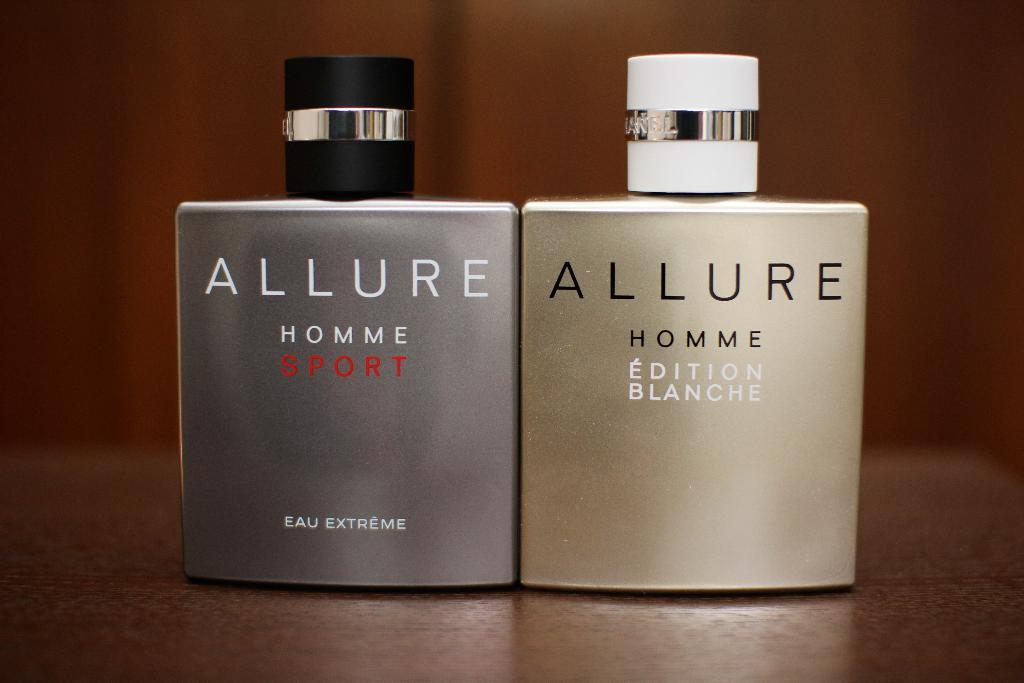<image>
Write a terse but informative summary of the picture. Two varieties of Allure cologne for men, one is Sport and the other is Edition Blanche 